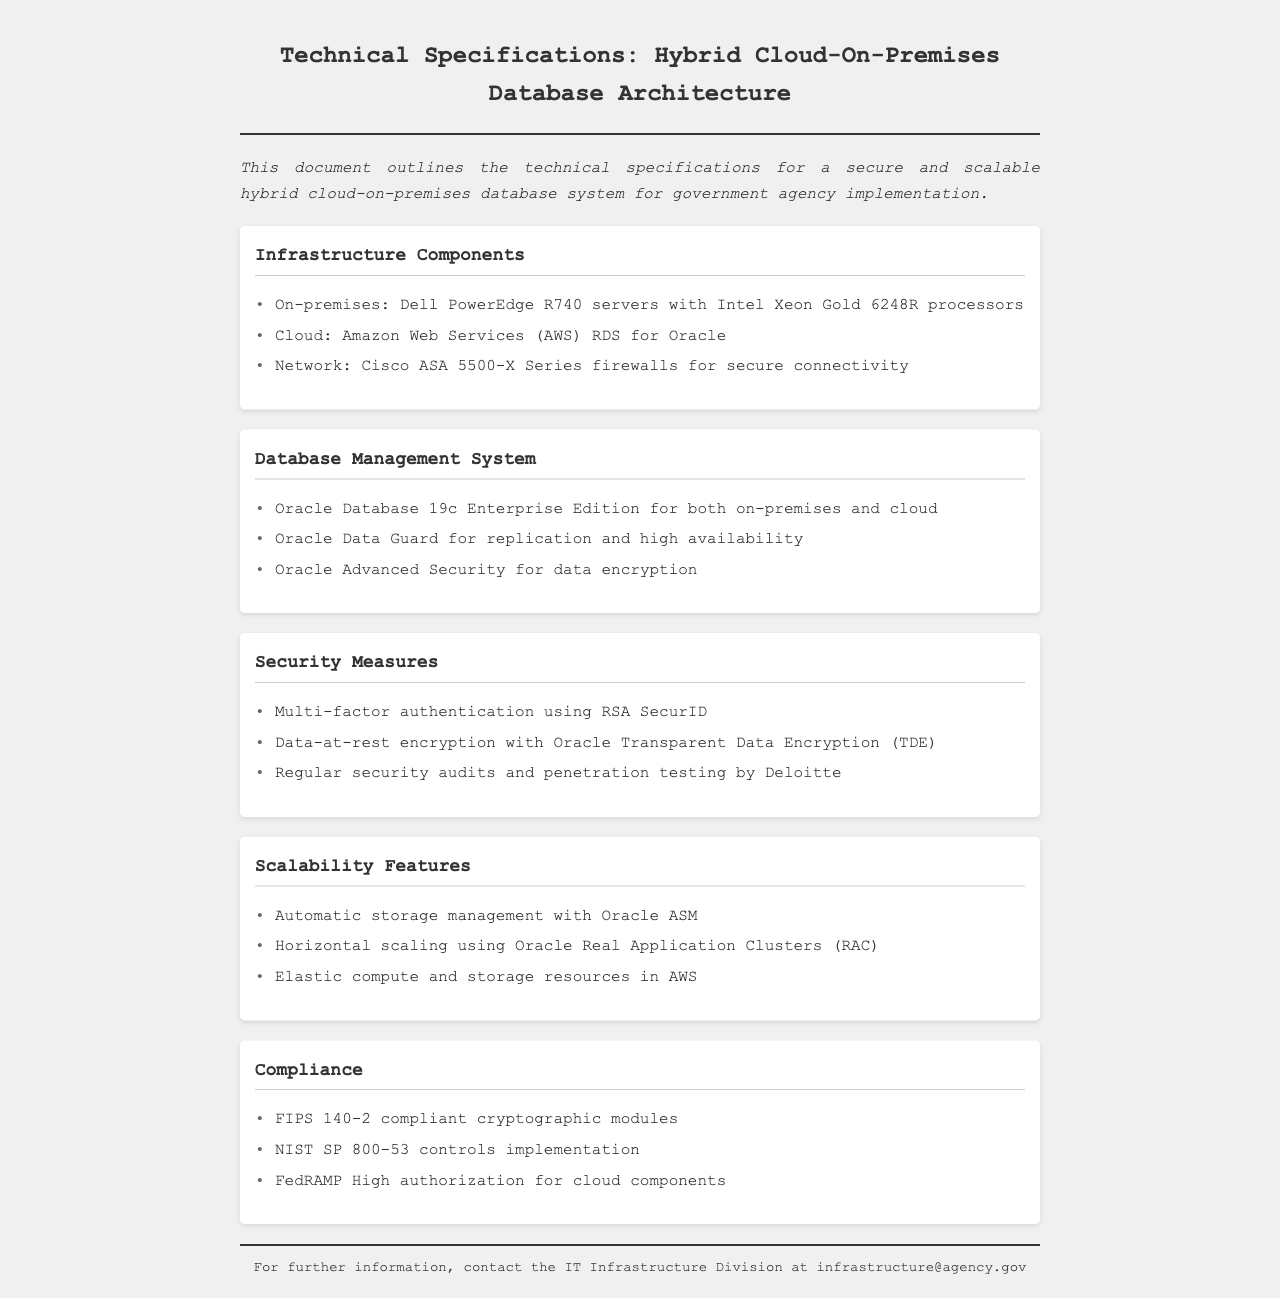What is the server model used on-premises? The document specifies that Dell PowerEdge R740 servers are used for on-premises infrastructure.
Answer: Dell PowerEdge R740 Which cloud service provider is mentioned in the document? The document mentions Amazon Web Services for cloud services.
Answer: Amazon Web Services What is the version of the Oracle Database stated for the database management system? The document notes that Oracle Database 19c Enterprise Edition is used for both on-premises and cloud.
Answer: Oracle Database 19c Enterprise Edition What type of authentication is used for security measures? The document indicates that multi-factor authentication is done using RSA SecurID.
Answer: RSA SecurID Which compliance standard is mentioned in regard to cryptographic modules? The document states that FIPS 140-2 compliant cryptographic modules are part of the compliance measures.
Answer: FIPS 140-2 What is the purpose of Oracle Data Guard in this architecture? Oracle Data Guard is mentioned for replication and high availability in the document.
Answer: Replication and high availability What security auditing firm is involved according to the document? The document specifies that security audits are conducted by Deloitte.
Answer: Deloitte How does the architecture support scalability according to the document? The document lists features like automatic storage management and horizontal scaling for scalability.
Answer: Automatic storage management and horizontal scaling 